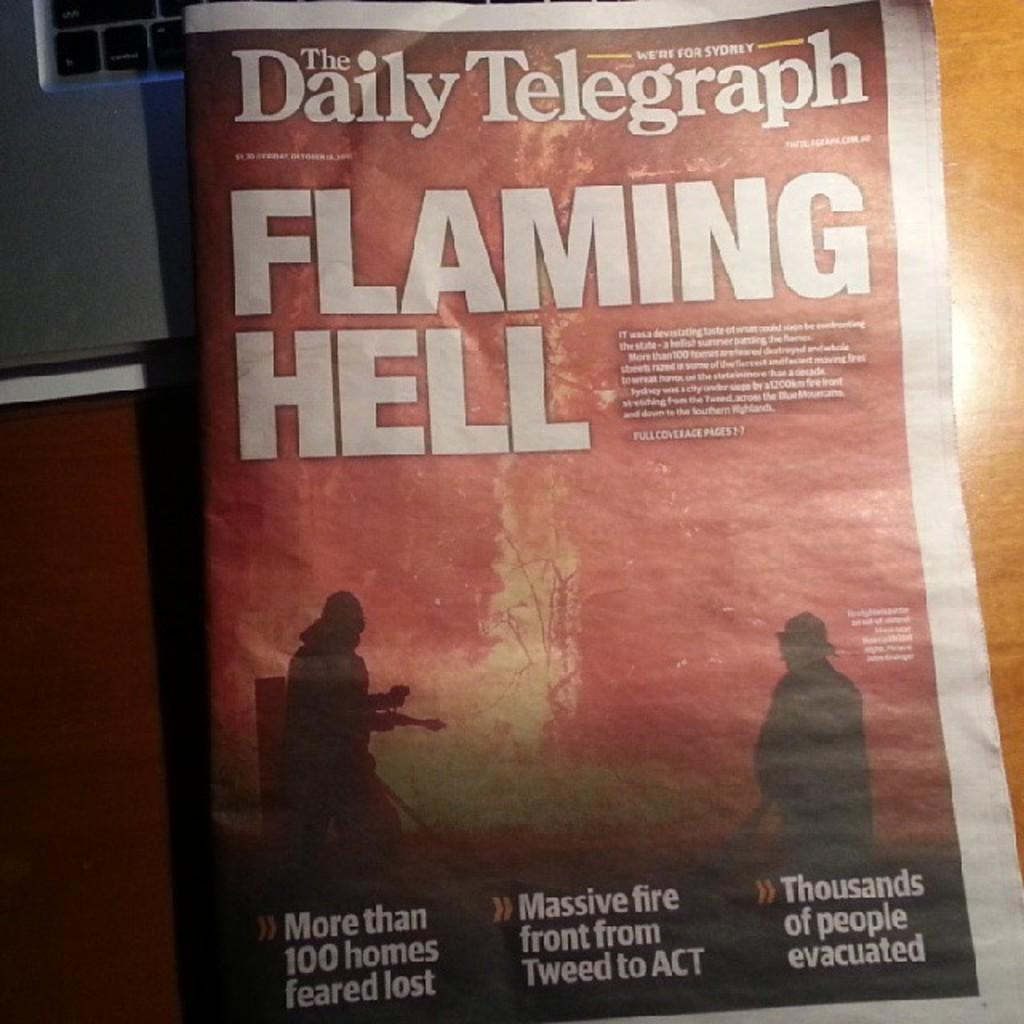<image>
Summarize the visual content of the image. A copy of the Daily Telegraph features a story titled "Flaming Hell." 